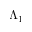<formula> <loc_0><loc_0><loc_500><loc_500>\Lambda _ { 1 }</formula> 